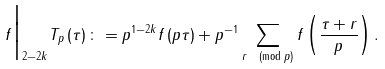Convert formula to latex. <formula><loc_0><loc_0><loc_500><loc_500>f \Big | _ { 2 - 2 k } T _ { p } \left ( \tau \right ) \colon = p ^ { 1 - 2 k } f \left ( p \tau \right ) + p ^ { - 1 } \sum _ { r \pmod { p } } f \left ( \frac { \tau + r } { p } \right ) .</formula> 